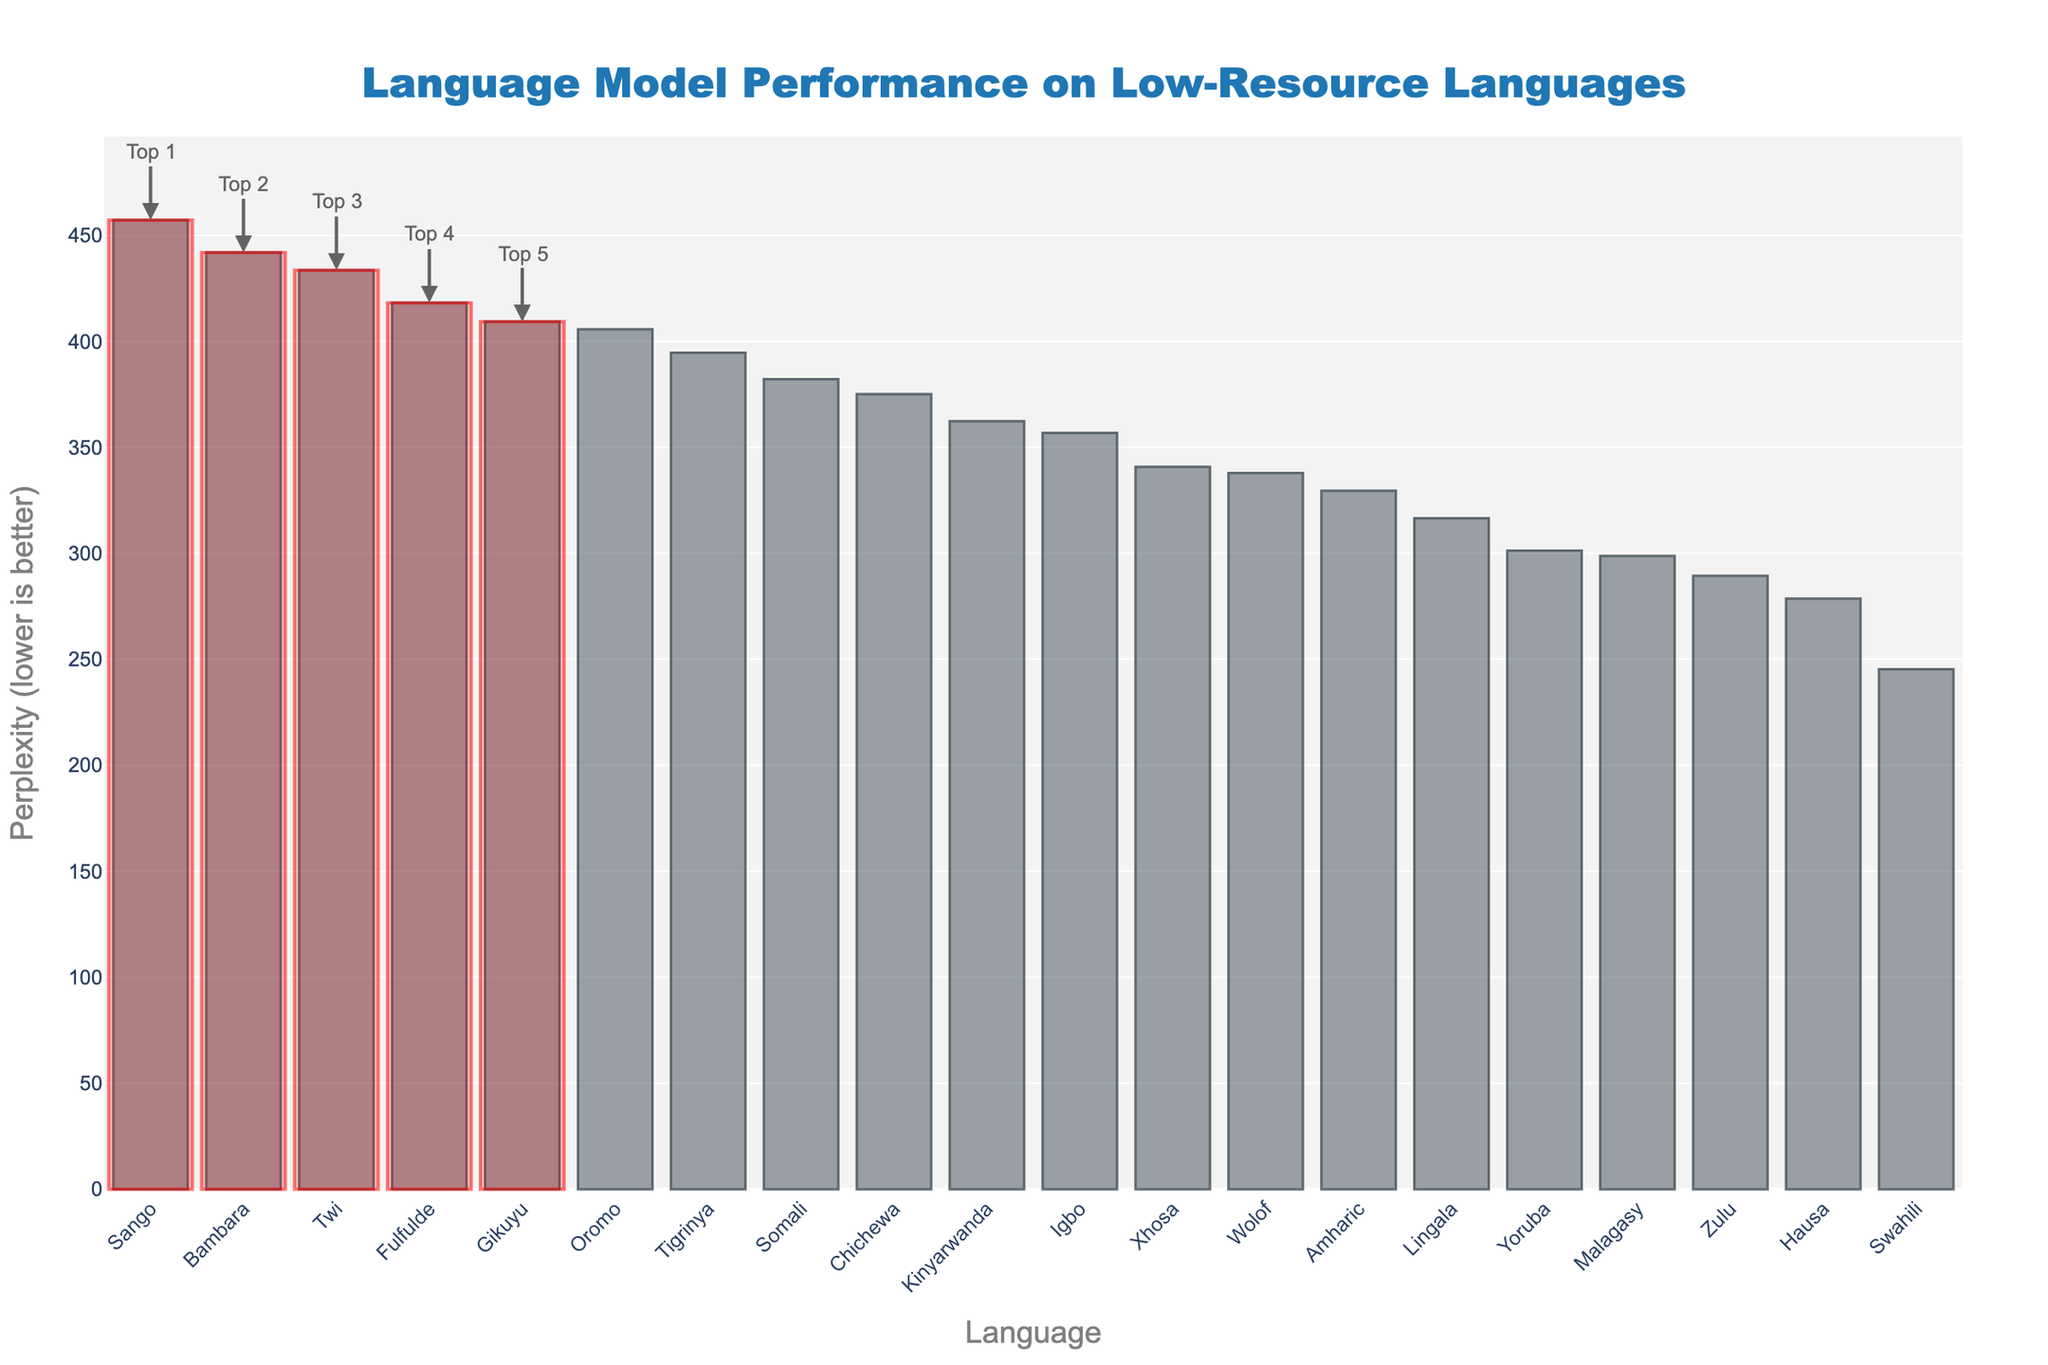Which language has the highest perplexity? The language with the highest perplexity is the one whose bar is the tallest on the bar chart. It is labeled as such.
Answer: Sango Which language has the lowest perplexity among the top 5 highlighted languages? Among the top 5 languages highlighted with a red rectangle, the shortest bar represents the language with the lowest perplexity. This can be identified by looking at the annotations as well.
Answer: Oromo What is the difference in perplexity between Fulfulde and Swahili? Identify the heights of the bars corresponding to Fulfulde and Swahili, then subtract the perplexity of Swahili from that of Fulfulde. Fulfulde has a perplexity of 418.2, and Swahili has 245.3. Therefore, the difference is 418.2 - 245.3.
Answer: 172.9 Which language has a perplexity higher than Amharic but lower than Somali? Locate the bars for Amharic and Somali and look for the bar whose height is in between these two. Check the corresponding language label.
Answer: Wolof What is the median perplexity of the languages listed? To find the median perplexity, first, sort all the perplexity values. Since there are 20 languages, the median is the average of the 10th and 11th values in the sorted list, which are Yoruba (301.2) and Malagasy (298.7). The median is then (301.2 + 298.7) / 2.
Answer: 299.95 Based on the color coding, how can you identify the languages in the top 5? The top 5 languages are highlighted with semi-transparent red rectangles, indicating they perform the best amongst the languages listed.
Answer: By looking for the red-highlighted bars Which two languages have the closest perplexities to each other and what are their values? Identify the two bars whose heights are closest. Zulu (289.4) and Yoruba (301.2) have the closest perplexity values. The difference between their perplexities (301.2 - 289.4) is 11.8.
Answer: Zulu: 289.4, Yoruba: 301.2 What is the average perplexity of all languages shown in the chart? Sum all the perplexity values and divide by the total number of languages (20). The values sum to 7431.5, hence the average is 7431.5 / 20.
Answer: 371.575 How does the performance of Yoruba compare to Hausa in terms of perplexity? Look at the heights of the bars for Yoruba and Hausa. Yoruba (301.2) has a higher perplexity than Hausa (278.6), indicating worse performance.
Answer: Yoruba has higher perplexity than Hausa 